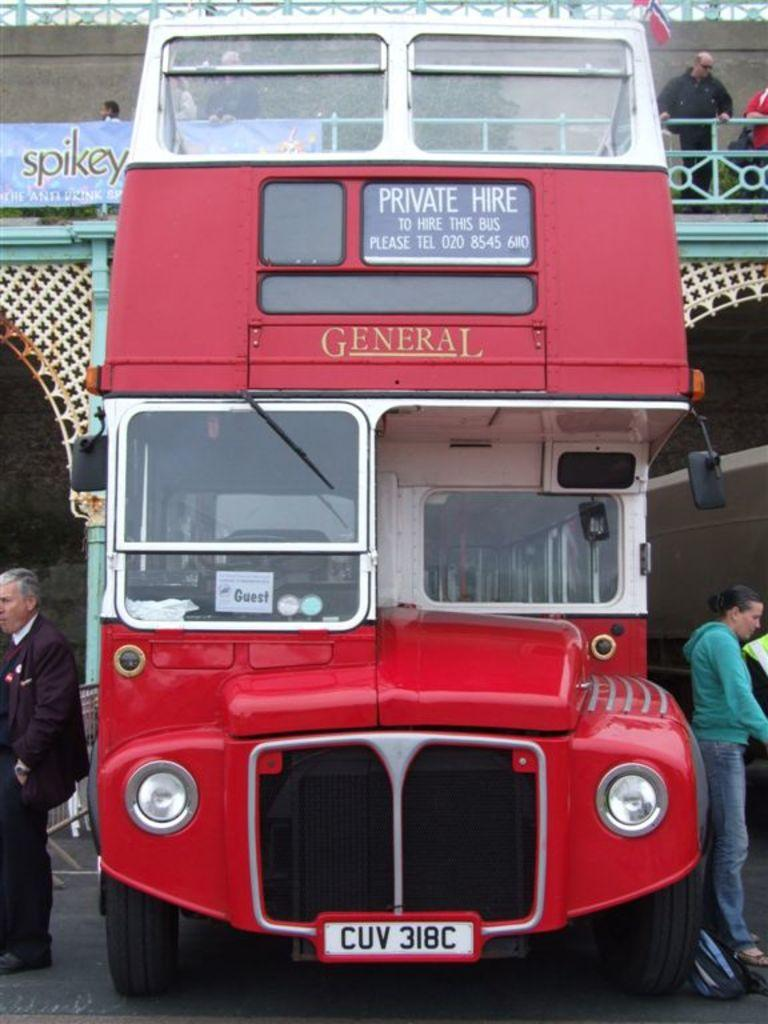What is the main subject in the center of the image? There is a bus in the center of the image. Where are the persons located in relation to the bus? There are persons on both the right and left sides of the image. What can be seen in the background of the image? There is a building and persons in the background of the image. What type of quilt is being used to decorate the bus in the image? There is no quilt present in the image, and the bus is not being decorated with one. 